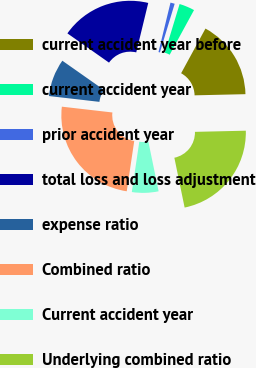Convert chart to OTSL. <chart><loc_0><loc_0><loc_500><loc_500><pie_chart><fcel>current accident year before<fcel>current accident year<fcel>prior accident year<fcel>total loss and loss adjustment<fcel>expense ratio<fcel>Combined ratio<fcel>Current accident year<fcel>Underlying combined ratio<nl><fcel>16.7%<fcel>3.25%<fcel>0.9%<fcel>19.04%<fcel>7.93%<fcel>24.47%<fcel>5.59%<fcel>22.13%<nl></chart> 